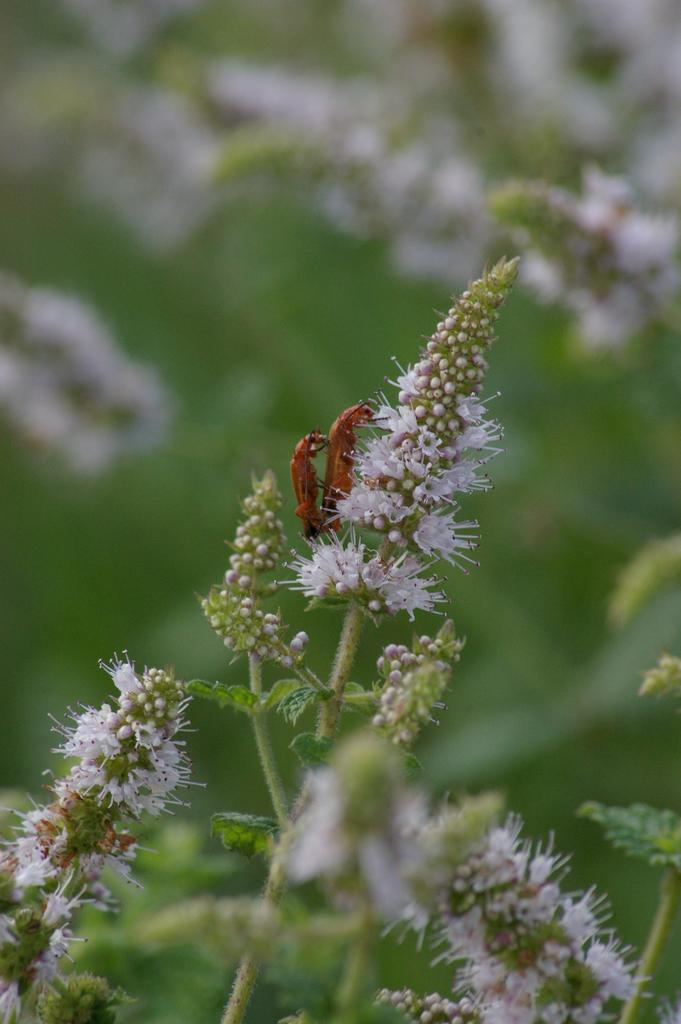What type of living organisms can be seen in the image? Insects can be seen in the image. What type of plants are also present in the image? Flowers are present in the image. Can you describe the background of the image? The background of the image is blurry. What time of day is depicted in the image? The time of day is not depicted in the image, as there are no indicators of time such as a clock or shadows. 